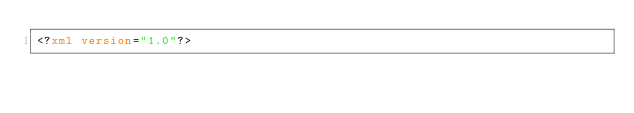Convert code to text. <code><loc_0><loc_0><loc_500><loc_500><_XML_><?xml version="1.0"?></code> 